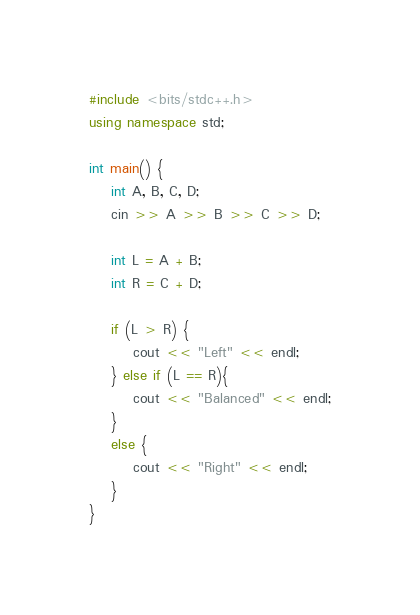<code> <loc_0><loc_0><loc_500><loc_500><_C++_>#include <bits/stdc++.h>
using namespace std;

int main() {
    int A, B, C, D;
    cin >> A >> B >> C >> D;

    int L = A + B;
    int R = C + D;

    if (L > R) {
        cout << "Left" << endl;
    } else if (L == R){
        cout << "Balanced" << endl;
    }
    else {
        cout << "Right" << endl;
    }
}</code> 